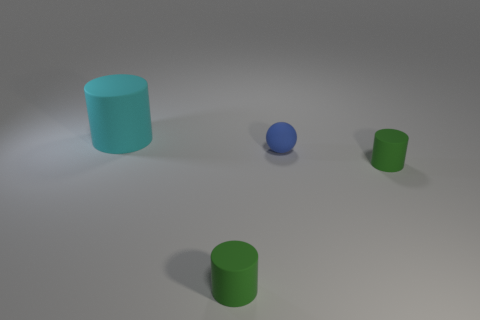How many other things are there of the same size as the cyan rubber cylinder?
Provide a short and direct response. 0. What is the size of the rubber cylinder behind the rubber sphere?
Keep it short and to the point. Large. How many things are the same material as the cyan cylinder?
Ensure brevity in your answer.  3. Does the green thing to the right of the small blue ball have the same shape as the large object?
Provide a succinct answer. Yes. What shape is the object that is behind the ball?
Provide a short and direct response. Cylinder. What is the material of the big cylinder?
Your answer should be very brief. Rubber. Does the tiny blue thing have the same shape as the cyan matte thing?
Provide a short and direct response. No. There is a thing that is to the left of the small sphere and in front of the blue matte thing; what is it made of?
Your answer should be compact. Rubber. How big is the blue matte thing?
Provide a short and direct response. Small. Is there any other thing that has the same color as the tiny matte sphere?
Your answer should be compact. No. 